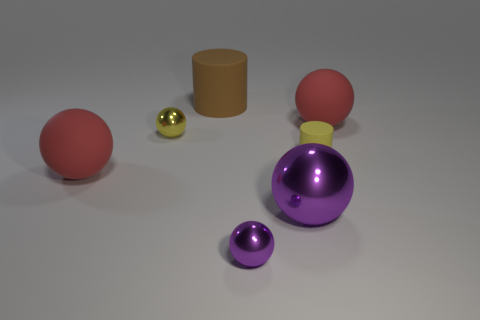How many purple balls must be subtracted to get 1 purple balls? 1 Subtract all blue balls. Subtract all green cylinders. How many balls are left? 5 Add 1 brown spheres. How many objects exist? 8 Subtract all balls. How many objects are left? 2 Subtract 2 red balls. How many objects are left? 5 Subtract all matte cylinders. Subtract all yellow metallic spheres. How many objects are left? 4 Add 4 small cylinders. How many small cylinders are left? 5 Add 6 large spheres. How many large spheres exist? 9 